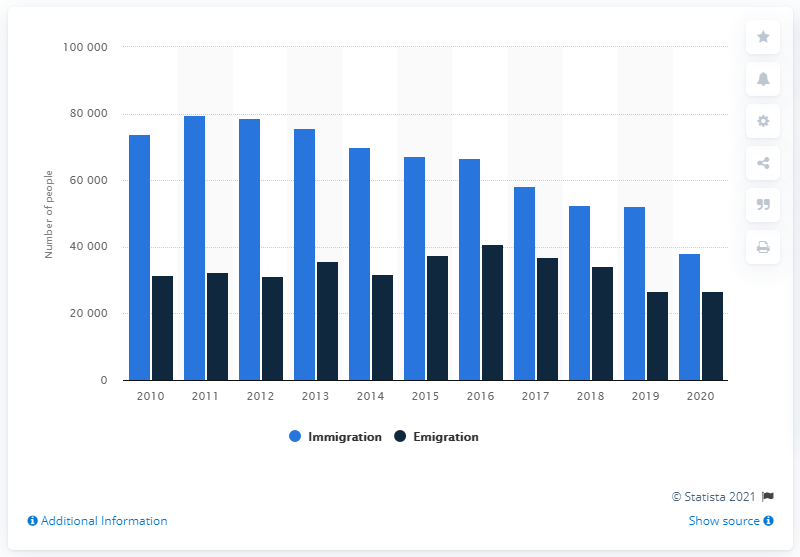Indicate a few pertinent items in this graphic. In 2020, 38,075 people immigrated to Norway. In 2011, a total of 79,498 individuals immigrated to Norway. In 2020, a total of 26,744 individuals emigrated to Norway. 